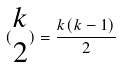<formula> <loc_0><loc_0><loc_500><loc_500>( \begin{matrix} k \\ 2 \end{matrix} ) = \frac { k ( k - 1 ) } { 2 }</formula> 